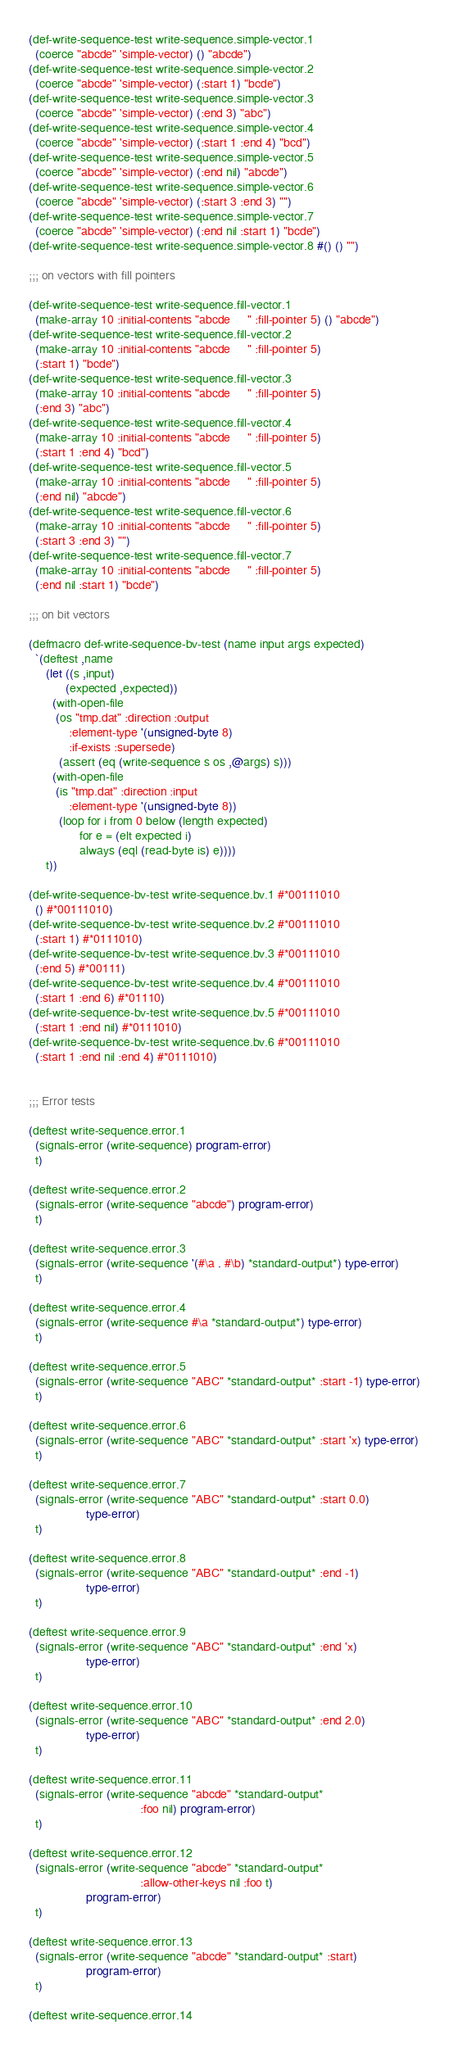<code> <loc_0><loc_0><loc_500><loc_500><_Lisp_>
(def-write-sequence-test write-sequence.simple-vector.1
  (coerce "abcde" 'simple-vector) () "abcde")
(def-write-sequence-test write-sequence.simple-vector.2
  (coerce "abcde" 'simple-vector) (:start 1) "bcde")
(def-write-sequence-test write-sequence.simple-vector.3
  (coerce "abcde" 'simple-vector) (:end 3) "abc")
(def-write-sequence-test write-sequence.simple-vector.4
  (coerce "abcde" 'simple-vector) (:start 1 :end 4) "bcd")
(def-write-sequence-test write-sequence.simple-vector.5
  (coerce "abcde" 'simple-vector) (:end nil) "abcde")
(def-write-sequence-test write-sequence.simple-vector.6
  (coerce "abcde" 'simple-vector) (:start 3 :end 3) "")
(def-write-sequence-test write-sequence.simple-vector.7
  (coerce "abcde" 'simple-vector) (:end nil :start 1) "bcde")
(def-write-sequence-test write-sequence.simple-vector.8 #() () "")

;;; on vectors with fill pointers

(def-write-sequence-test write-sequence.fill-vector.1
  (make-array 10 :initial-contents "abcde     " :fill-pointer 5) () "abcde")
(def-write-sequence-test write-sequence.fill-vector.2
  (make-array 10 :initial-contents "abcde     " :fill-pointer 5)
  (:start 1) "bcde")
(def-write-sequence-test write-sequence.fill-vector.3
  (make-array 10 :initial-contents "abcde     " :fill-pointer 5)
  (:end 3) "abc")
(def-write-sequence-test write-sequence.fill-vector.4
  (make-array 10 :initial-contents "abcde     " :fill-pointer 5)
  (:start 1 :end 4) "bcd")
(def-write-sequence-test write-sequence.fill-vector.5
  (make-array 10 :initial-contents "abcde     " :fill-pointer 5)
  (:end nil) "abcde")
(def-write-sequence-test write-sequence.fill-vector.6
  (make-array 10 :initial-contents "abcde     " :fill-pointer 5)
  (:start 3 :end 3) "")
(def-write-sequence-test write-sequence.fill-vector.7
  (make-array 10 :initial-contents "abcde     " :fill-pointer 5)
  (:end nil :start 1) "bcde")

;;; on bit vectors

(defmacro def-write-sequence-bv-test (name input args expected)
  `(deftest ,name
     (let ((s ,input)
           (expected ,expected))
       (with-open-file
        (os "tmp.dat" :direction :output
            :element-type '(unsigned-byte 8)
            :if-exists :supersede)
         (assert (eq (write-sequence s os ,@args) s)))
       (with-open-file
        (is "tmp.dat" :direction :input
            :element-type '(unsigned-byte 8))
         (loop for i from 0 below (length expected)
               for e = (elt expected i)
               always (eql (read-byte is) e))))
     t))

(def-write-sequence-bv-test write-sequence.bv.1 #*00111010
  () #*00111010)
(def-write-sequence-bv-test write-sequence.bv.2 #*00111010
  (:start 1) #*0111010)
(def-write-sequence-bv-test write-sequence.bv.3 #*00111010
  (:end 5) #*00111)
(def-write-sequence-bv-test write-sequence.bv.4 #*00111010
  (:start 1 :end 6) #*01110)
(def-write-sequence-bv-test write-sequence.bv.5 #*00111010
  (:start 1 :end nil) #*0111010)
(def-write-sequence-bv-test write-sequence.bv.6 #*00111010
  (:start 1 :end nil :end 4) #*0111010)


;;; Error tests

(deftest write-sequence.error.1
  (signals-error (write-sequence) program-error)
  t)

(deftest write-sequence.error.2
  (signals-error (write-sequence "abcde") program-error)
  t)

(deftest write-sequence.error.3
  (signals-error (write-sequence '(#\a . #\b) *standard-output*) type-error)
  t)

(deftest write-sequence.error.4
  (signals-error (write-sequence #\a *standard-output*) type-error)
  t)

(deftest write-sequence.error.5
  (signals-error (write-sequence "ABC" *standard-output* :start -1) type-error)
  t)

(deftest write-sequence.error.6
  (signals-error (write-sequence "ABC" *standard-output* :start 'x) type-error)
  t)

(deftest write-sequence.error.7
  (signals-error (write-sequence "ABC" *standard-output* :start 0.0)
                 type-error)
  t)

(deftest write-sequence.error.8
  (signals-error (write-sequence "ABC" *standard-output* :end -1)
                 type-error)
  t)

(deftest write-sequence.error.9
  (signals-error (write-sequence "ABC" *standard-output* :end 'x)
                 type-error)
  t)

(deftest write-sequence.error.10
  (signals-error (write-sequence "ABC" *standard-output* :end 2.0)
                 type-error)
  t)

(deftest write-sequence.error.11
  (signals-error (write-sequence "abcde" *standard-output*
                                 :foo nil) program-error)
  t)

(deftest write-sequence.error.12
  (signals-error (write-sequence "abcde" *standard-output*
                                 :allow-other-keys nil :foo t)
                 program-error)
  t)

(deftest write-sequence.error.13
  (signals-error (write-sequence "abcde" *standard-output* :start)
                 program-error)
  t)

(deftest write-sequence.error.14</code> 